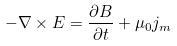Convert formula to latex. <formula><loc_0><loc_0><loc_500><loc_500>- \nabla \times E = { \frac { \partial B } { \partial t } } + \mu _ { 0 } j _ { m }</formula> 